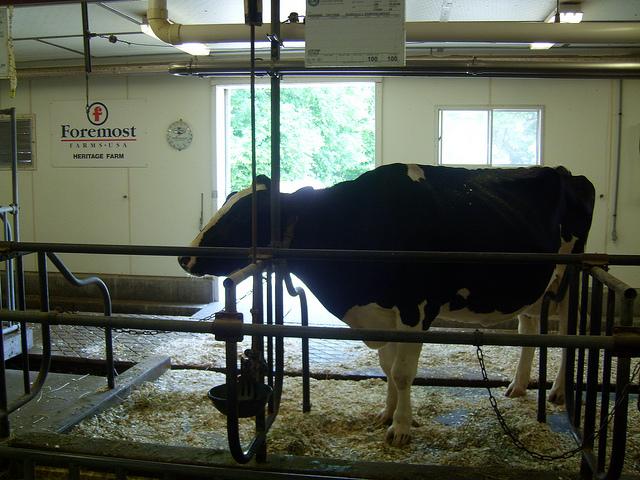Is the cow free to graze?
Give a very brief answer. No. What colors is the cow?
Quick response, please. Black and white. What do cows give us to drink?
Quick response, please. Milk. 